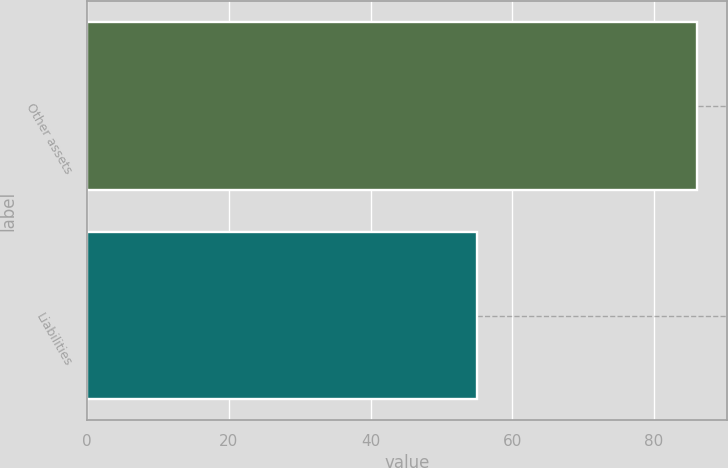<chart> <loc_0><loc_0><loc_500><loc_500><bar_chart><fcel>Other assets<fcel>Liabilities<nl><fcel>86<fcel>55<nl></chart> 